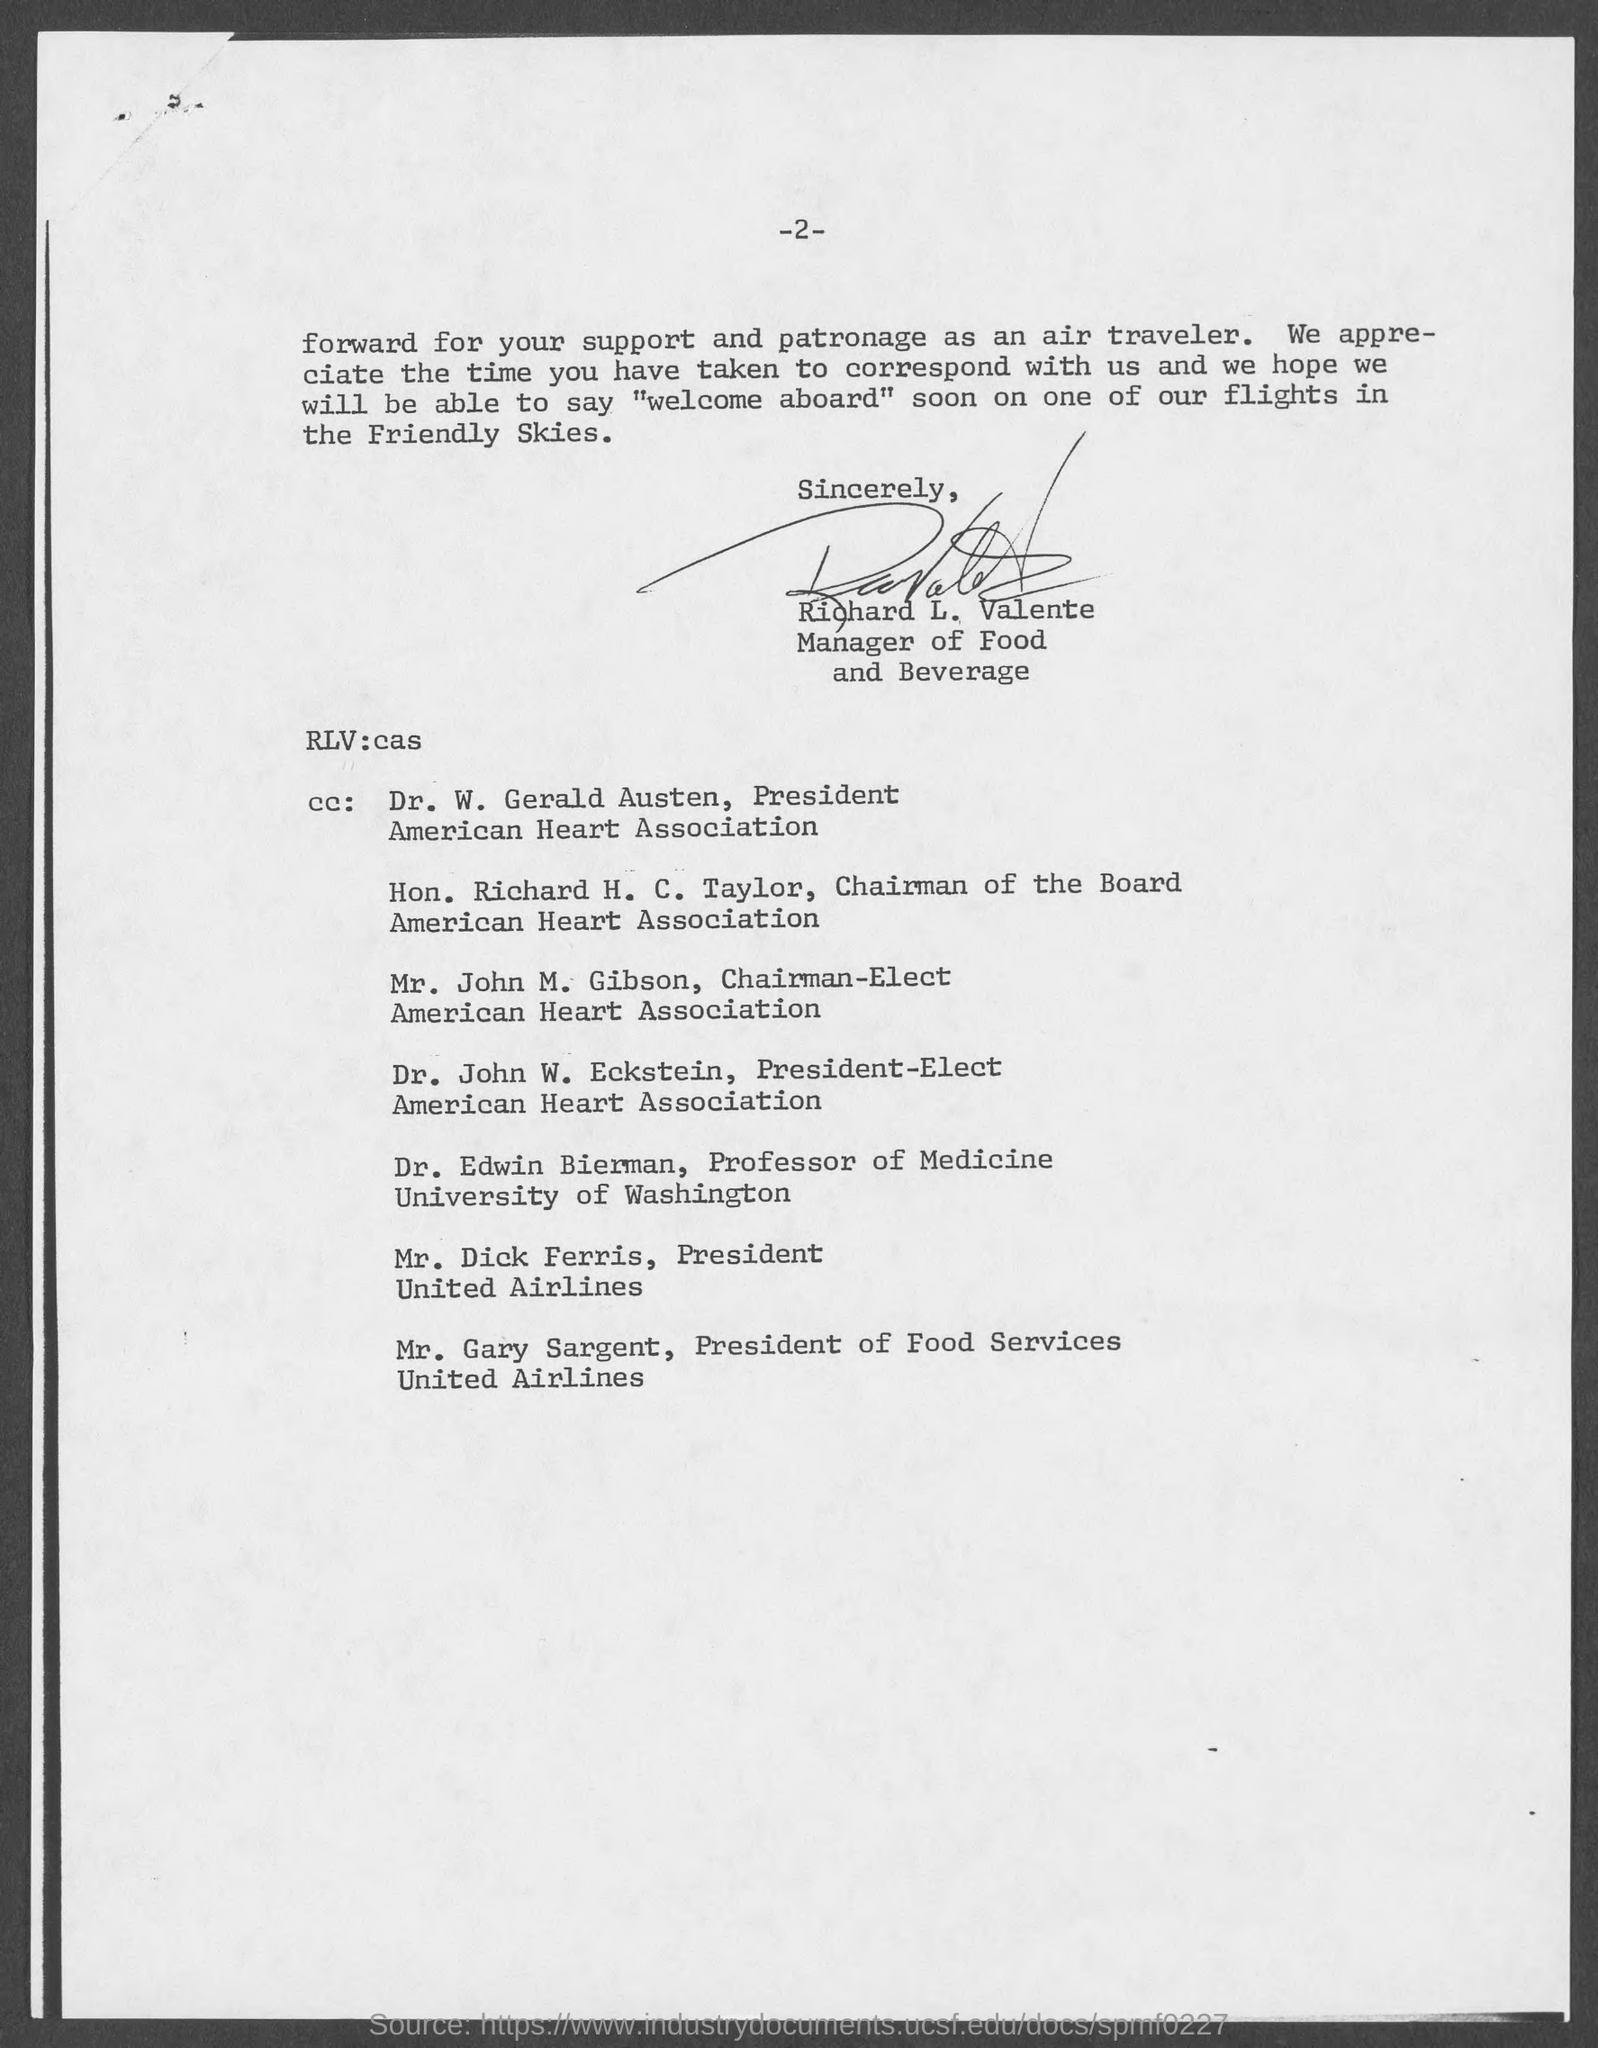What is the page number at top of the page?
Ensure brevity in your answer.  2. Who is the manager of food and beverage ?
Ensure brevity in your answer.  Richard L. Valente. Who is the president, american heart association ?
Keep it short and to the point. Dr. W. Gerald Austen. Who is the chairman of the board, american heart association ?
Offer a terse response. Hon. Richard H. C. Taylor. Who is the president- elect, american heart association ?
Offer a very short reply. Dr. John W. Eckstein. Who is the president, united airlines ?
Your answer should be compact. Mr. Dick Ferris. Who is the president of food services, united airlines ?
Give a very brief answer. Mr. Gary Sargent. 